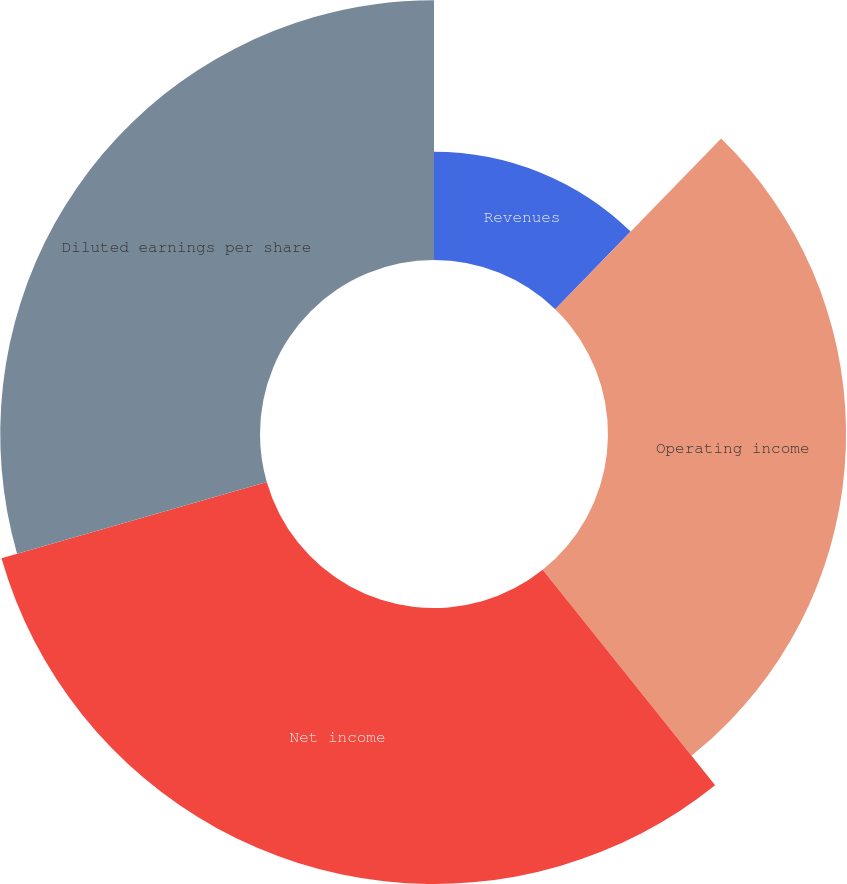<chart> <loc_0><loc_0><loc_500><loc_500><pie_chart><fcel>Revenues<fcel>Operating income<fcel>Net income<fcel>Diluted earnings per share<nl><fcel>12.27%<fcel>26.99%<fcel>31.29%<fcel>29.45%<nl></chart> 